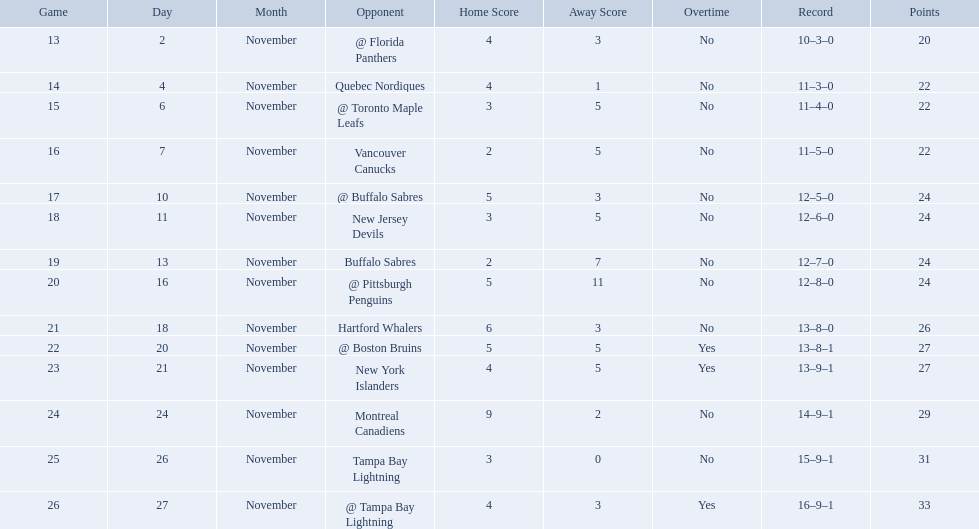Who did the philadelphia flyers play in game 17? @ Buffalo Sabres. What was the score of the november 10th game against the buffalo sabres? 5–3. Which team in the atlantic division had less points than the philadelphia flyers? Tampa Bay Lightning. Who are all of the teams? @ Florida Panthers, Quebec Nordiques, @ Toronto Maple Leafs, Vancouver Canucks, @ Buffalo Sabres, New Jersey Devils, Buffalo Sabres, @ Pittsburgh Penguins, Hartford Whalers, @ Boston Bruins, New York Islanders, Montreal Canadiens, Tampa Bay Lightning. What games finished in overtime? 22, 23, 26. In game number 23, who did they face? New York Islanders. What were the scores of the 1993-94 philadelphia flyers season? 4–3, 4–1, 3–5, 2–5, 5–3, 3–5, 2–7, 5–11, 6–3, 5–5 OT, 4–5 OT, 9–2, 3–0, 4–3 OT. Which of these teams had the score 4-5 ot? New York Islanders. 